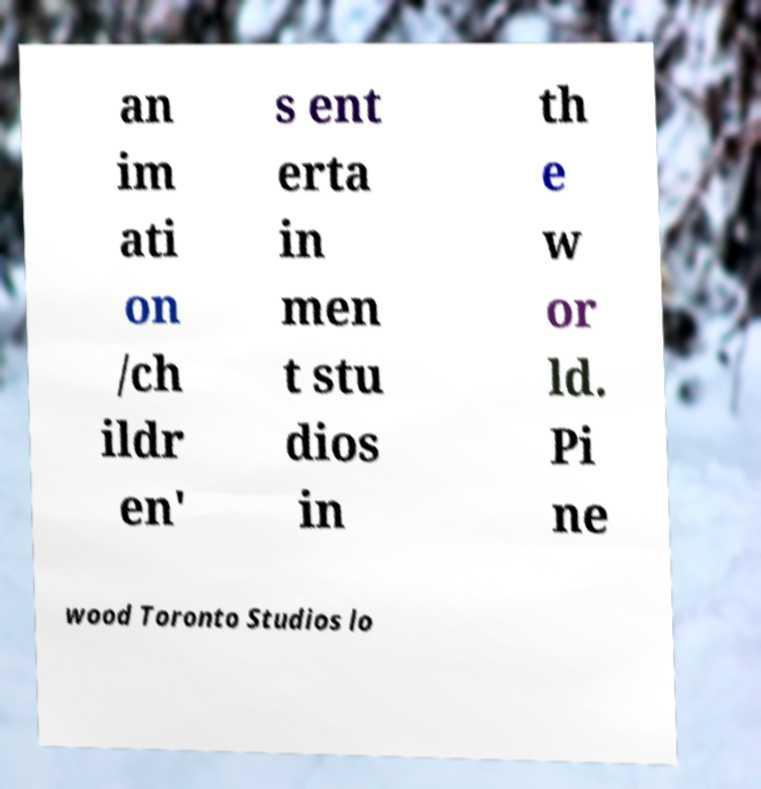Could you extract and type out the text from this image? an im ati on /ch ildr en' s ent erta in men t stu dios in th e w or ld. Pi ne wood Toronto Studios lo 